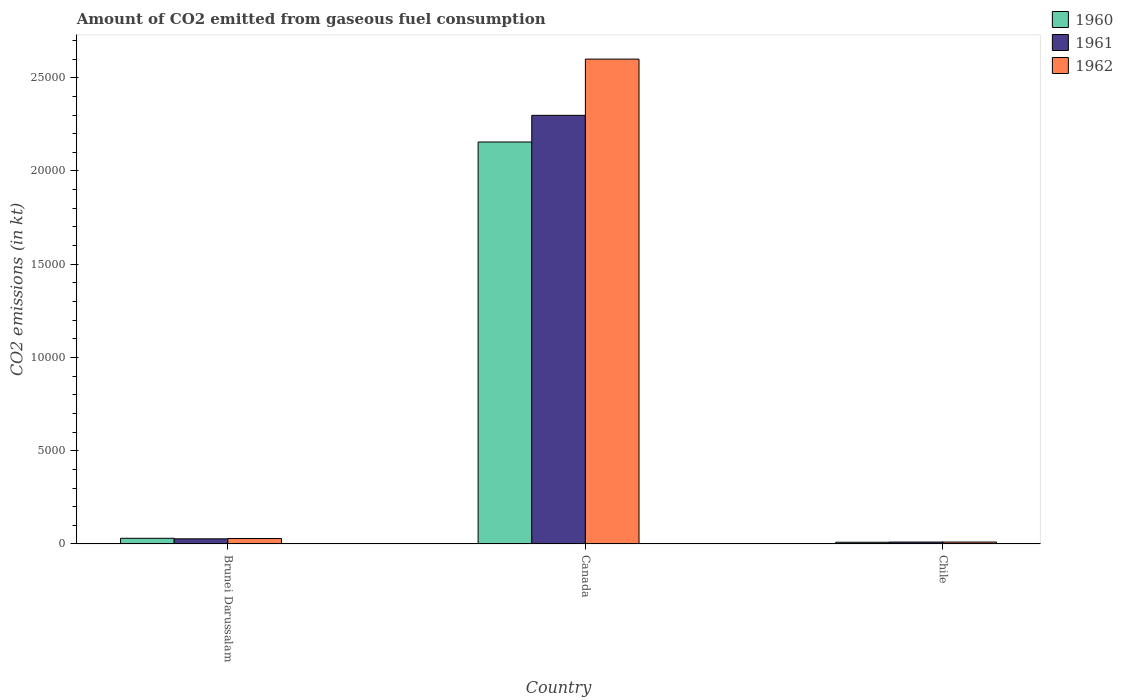How many different coloured bars are there?
Offer a very short reply. 3. How many groups of bars are there?
Offer a very short reply. 3. Are the number of bars on each tick of the X-axis equal?
Provide a succinct answer. Yes. How many bars are there on the 1st tick from the right?
Make the answer very short. 3. What is the label of the 1st group of bars from the left?
Your response must be concise. Brunei Darussalam. What is the amount of CO2 emitted in 1962 in Brunei Darussalam?
Your response must be concise. 293.36. Across all countries, what is the maximum amount of CO2 emitted in 1960?
Keep it short and to the point. 2.16e+04. Across all countries, what is the minimum amount of CO2 emitted in 1961?
Provide a succinct answer. 102.68. In which country was the amount of CO2 emitted in 1960 maximum?
Your answer should be compact. Canada. In which country was the amount of CO2 emitted in 1962 minimum?
Offer a terse response. Chile. What is the total amount of CO2 emitted in 1962 in the graph?
Make the answer very short. 2.64e+04. What is the difference between the amount of CO2 emitted in 1960 in Canada and that in Chile?
Provide a short and direct response. 2.15e+04. What is the difference between the amount of CO2 emitted in 1962 in Canada and the amount of CO2 emitted in 1961 in Chile?
Offer a terse response. 2.59e+04. What is the average amount of CO2 emitted in 1961 per country?
Your answer should be very brief. 7787.49. What is the difference between the amount of CO2 emitted of/in 1962 and amount of CO2 emitted of/in 1961 in Canada?
Keep it short and to the point. 3014.27. What is the ratio of the amount of CO2 emitted in 1961 in Brunei Darussalam to that in Chile?
Provide a succinct answer. 2.68. Is the amount of CO2 emitted in 1960 in Canada less than that in Chile?
Your answer should be compact. No. What is the difference between the highest and the second highest amount of CO2 emitted in 1960?
Keep it short and to the point. -2.13e+04. What is the difference between the highest and the lowest amount of CO2 emitted in 1962?
Give a very brief answer. 2.59e+04. What does the 3rd bar from the left in Brunei Darussalam represents?
Your response must be concise. 1962. How many countries are there in the graph?
Your response must be concise. 3. What is the difference between two consecutive major ticks on the Y-axis?
Your answer should be compact. 5000. Are the values on the major ticks of Y-axis written in scientific E-notation?
Provide a short and direct response. No. Does the graph contain grids?
Your response must be concise. No. Where does the legend appear in the graph?
Keep it short and to the point. Top right. How many legend labels are there?
Provide a short and direct response. 3. What is the title of the graph?
Keep it short and to the point. Amount of CO2 emitted from gaseous fuel consumption. What is the label or title of the X-axis?
Your response must be concise. Country. What is the label or title of the Y-axis?
Ensure brevity in your answer.  CO2 emissions (in kt). What is the CO2 emissions (in kt) of 1960 in Brunei Darussalam?
Ensure brevity in your answer.  304.36. What is the CO2 emissions (in kt) of 1961 in Brunei Darussalam?
Your response must be concise. 275.02. What is the CO2 emissions (in kt) of 1962 in Brunei Darussalam?
Your response must be concise. 293.36. What is the CO2 emissions (in kt) of 1960 in Canada?
Offer a terse response. 2.16e+04. What is the CO2 emissions (in kt) of 1961 in Canada?
Your answer should be compact. 2.30e+04. What is the CO2 emissions (in kt) of 1962 in Canada?
Offer a very short reply. 2.60e+04. What is the CO2 emissions (in kt) in 1960 in Chile?
Your response must be concise. 91.67. What is the CO2 emissions (in kt) in 1961 in Chile?
Make the answer very short. 102.68. What is the CO2 emissions (in kt) of 1962 in Chile?
Your answer should be very brief. 102.68. Across all countries, what is the maximum CO2 emissions (in kt) in 1960?
Give a very brief answer. 2.16e+04. Across all countries, what is the maximum CO2 emissions (in kt) in 1961?
Your answer should be compact. 2.30e+04. Across all countries, what is the maximum CO2 emissions (in kt) in 1962?
Keep it short and to the point. 2.60e+04. Across all countries, what is the minimum CO2 emissions (in kt) in 1960?
Give a very brief answer. 91.67. Across all countries, what is the minimum CO2 emissions (in kt) in 1961?
Provide a short and direct response. 102.68. Across all countries, what is the minimum CO2 emissions (in kt) of 1962?
Keep it short and to the point. 102.68. What is the total CO2 emissions (in kt) of 1960 in the graph?
Keep it short and to the point. 2.20e+04. What is the total CO2 emissions (in kt) of 1961 in the graph?
Offer a very short reply. 2.34e+04. What is the total CO2 emissions (in kt) of 1962 in the graph?
Your answer should be very brief. 2.64e+04. What is the difference between the CO2 emissions (in kt) of 1960 in Brunei Darussalam and that in Canada?
Your answer should be compact. -2.13e+04. What is the difference between the CO2 emissions (in kt) of 1961 in Brunei Darussalam and that in Canada?
Provide a succinct answer. -2.27e+04. What is the difference between the CO2 emissions (in kt) in 1962 in Brunei Darussalam and that in Canada?
Keep it short and to the point. -2.57e+04. What is the difference between the CO2 emissions (in kt) in 1960 in Brunei Darussalam and that in Chile?
Your answer should be very brief. 212.69. What is the difference between the CO2 emissions (in kt) in 1961 in Brunei Darussalam and that in Chile?
Your answer should be very brief. 172.35. What is the difference between the CO2 emissions (in kt) in 1962 in Brunei Darussalam and that in Chile?
Provide a succinct answer. 190.68. What is the difference between the CO2 emissions (in kt) of 1960 in Canada and that in Chile?
Provide a succinct answer. 2.15e+04. What is the difference between the CO2 emissions (in kt) of 1961 in Canada and that in Chile?
Your answer should be compact. 2.29e+04. What is the difference between the CO2 emissions (in kt) in 1962 in Canada and that in Chile?
Offer a terse response. 2.59e+04. What is the difference between the CO2 emissions (in kt) in 1960 in Brunei Darussalam and the CO2 emissions (in kt) in 1961 in Canada?
Your answer should be very brief. -2.27e+04. What is the difference between the CO2 emissions (in kt) in 1960 in Brunei Darussalam and the CO2 emissions (in kt) in 1962 in Canada?
Provide a succinct answer. -2.57e+04. What is the difference between the CO2 emissions (in kt) of 1961 in Brunei Darussalam and the CO2 emissions (in kt) of 1962 in Canada?
Give a very brief answer. -2.57e+04. What is the difference between the CO2 emissions (in kt) of 1960 in Brunei Darussalam and the CO2 emissions (in kt) of 1961 in Chile?
Your response must be concise. 201.69. What is the difference between the CO2 emissions (in kt) of 1960 in Brunei Darussalam and the CO2 emissions (in kt) of 1962 in Chile?
Offer a very short reply. 201.69. What is the difference between the CO2 emissions (in kt) of 1961 in Brunei Darussalam and the CO2 emissions (in kt) of 1962 in Chile?
Offer a very short reply. 172.35. What is the difference between the CO2 emissions (in kt) of 1960 in Canada and the CO2 emissions (in kt) of 1961 in Chile?
Provide a succinct answer. 2.15e+04. What is the difference between the CO2 emissions (in kt) of 1960 in Canada and the CO2 emissions (in kt) of 1962 in Chile?
Keep it short and to the point. 2.15e+04. What is the difference between the CO2 emissions (in kt) of 1961 in Canada and the CO2 emissions (in kt) of 1962 in Chile?
Give a very brief answer. 2.29e+04. What is the average CO2 emissions (in kt) of 1960 per country?
Keep it short and to the point. 7316.89. What is the average CO2 emissions (in kt) of 1961 per country?
Give a very brief answer. 7787.49. What is the average CO2 emissions (in kt) in 1962 per country?
Your answer should be very brief. 8798.36. What is the difference between the CO2 emissions (in kt) in 1960 and CO2 emissions (in kt) in 1961 in Brunei Darussalam?
Your response must be concise. 29.34. What is the difference between the CO2 emissions (in kt) in 1960 and CO2 emissions (in kt) in 1962 in Brunei Darussalam?
Provide a short and direct response. 11. What is the difference between the CO2 emissions (in kt) of 1961 and CO2 emissions (in kt) of 1962 in Brunei Darussalam?
Keep it short and to the point. -18.34. What is the difference between the CO2 emissions (in kt) in 1960 and CO2 emissions (in kt) in 1961 in Canada?
Your response must be concise. -1430.13. What is the difference between the CO2 emissions (in kt) in 1960 and CO2 emissions (in kt) in 1962 in Canada?
Provide a short and direct response. -4444.4. What is the difference between the CO2 emissions (in kt) in 1961 and CO2 emissions (in kt) in 1962 in Canada?
Your answer should be very brief. -3014.27. What is the difference between the CO2 emissions (in kt) in 1960 and CO2 emissions (in kt) in 1961 in Chile?
Give a very brief answer. -11. What is the difference between the CO2 emissions (in kt) in 1960 and CO2 emissions (in kt) in 1962 in Chile?
Keep it short and to the point. -11. What is the difference between the CO2 emissions (in kt) in 1961 and CO2 emissions (in kt) in 1962 in Chile?
Keep it short and to the point. 0. What is the ratio of the CO2 emissions (in kt) of 1960 in Brunei Darussalam to that in Canada?
Give a very brief answer. 0.01. What is the ratio of the CO2 emissions (in kt) in 1961 in Brunei Darussalam to that in Canada?
Ensure brevity in your answer.  0.01. What is the ratio of the CO2 emissions (in kt) of 1962 in Brunei Darussalam to that in Canada?
Your answer should be compact. 0.01. What is the ratio of the CO2 emissions (in kt) of 1960 in Brunei Darussalam to that in Chile?
Your answer should be very brief. 3.32. What is the ratio of the CO2 emissions (in kt) in 1961 in Brunei Darussalam to that in Chile?
Provide a short and direct response. 2.68. What is the ratio of the CO2 emissions (in kt) of 1962 in Brunei Darussalam to that in Chile?
Provide a succinct answer. 2.86. What is the ratio of the CO2 emissions (in kt) of 1960 in Canada to that in Chile?
Your response must be concise. 235.12. What is the ratio of the CO2 emissions (in kt) in 1961 in Canada to that in Chile?
Your response must be concise. 223.86. What is the ratio of the CO2 emissions (in kt) of 1962 in Canada to that in Chile?
Your answer should be compact. 253.21. What is the difference between the highest and the second highest CO2 emissions (in kt) in 1960?
Your answer should be very brief. 2.13e+04. What is the difference between the highest and the second highest CO2 emissions (in kt) in 1961?
Offer a very short reply. 2.27e+04. What is the difference between the highest and the second highest CO2 emissions (in kt) in 1962?
Provide a short and direct response. 2.57e+04. What is the difference between the highest and the lowest CO2 emissions (in kt) of 1960?
Offer a very short reply. 2.15e+04. What is the difference between the highest and the lowest CO2 emissions (in kt) in 1961?
Your answer should be compact. 2.29e+04. What is the difference between the highest and the lowest CO2 emissions (in kt) in 1962?
Provide a short and direct response. 2.59e+04. 